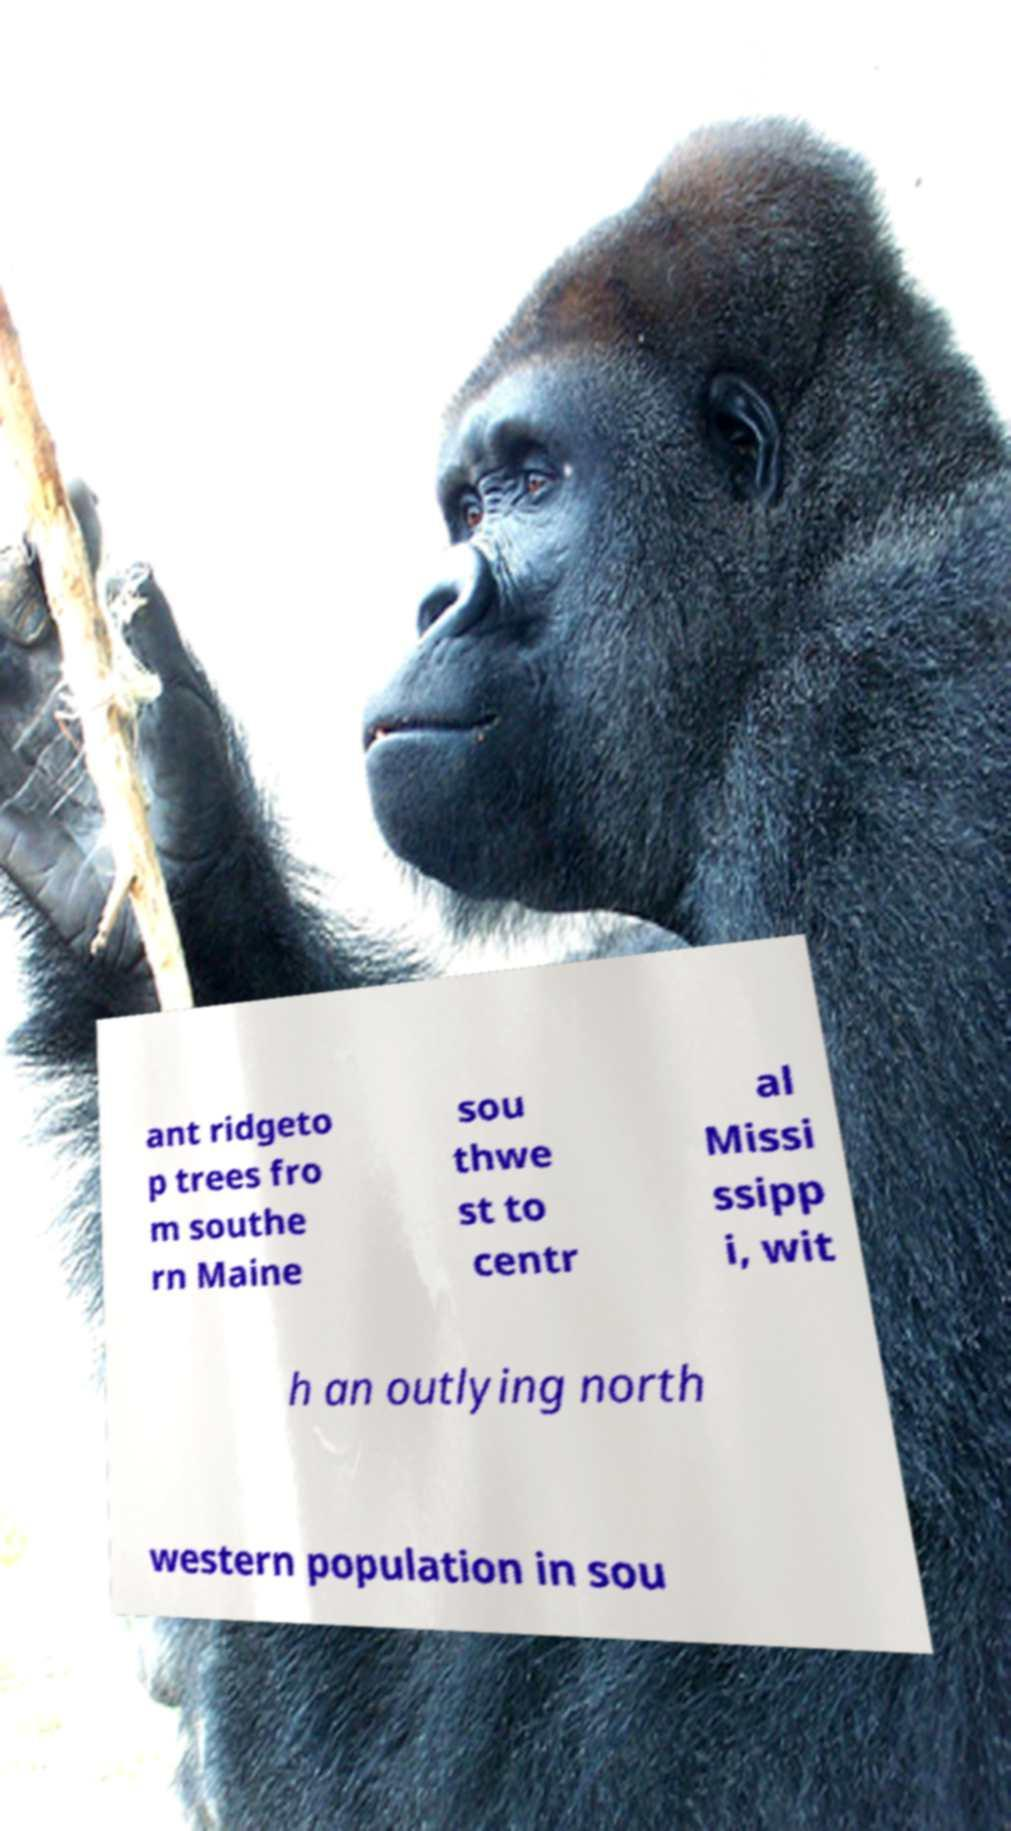What messages or text are displayed in this image? I need them in a readable, typed format. ant ridgeto p trees fro m southe rn Maine sou thwe st to centr al Missi ssipp i, wit h an outlying north western population in sou 